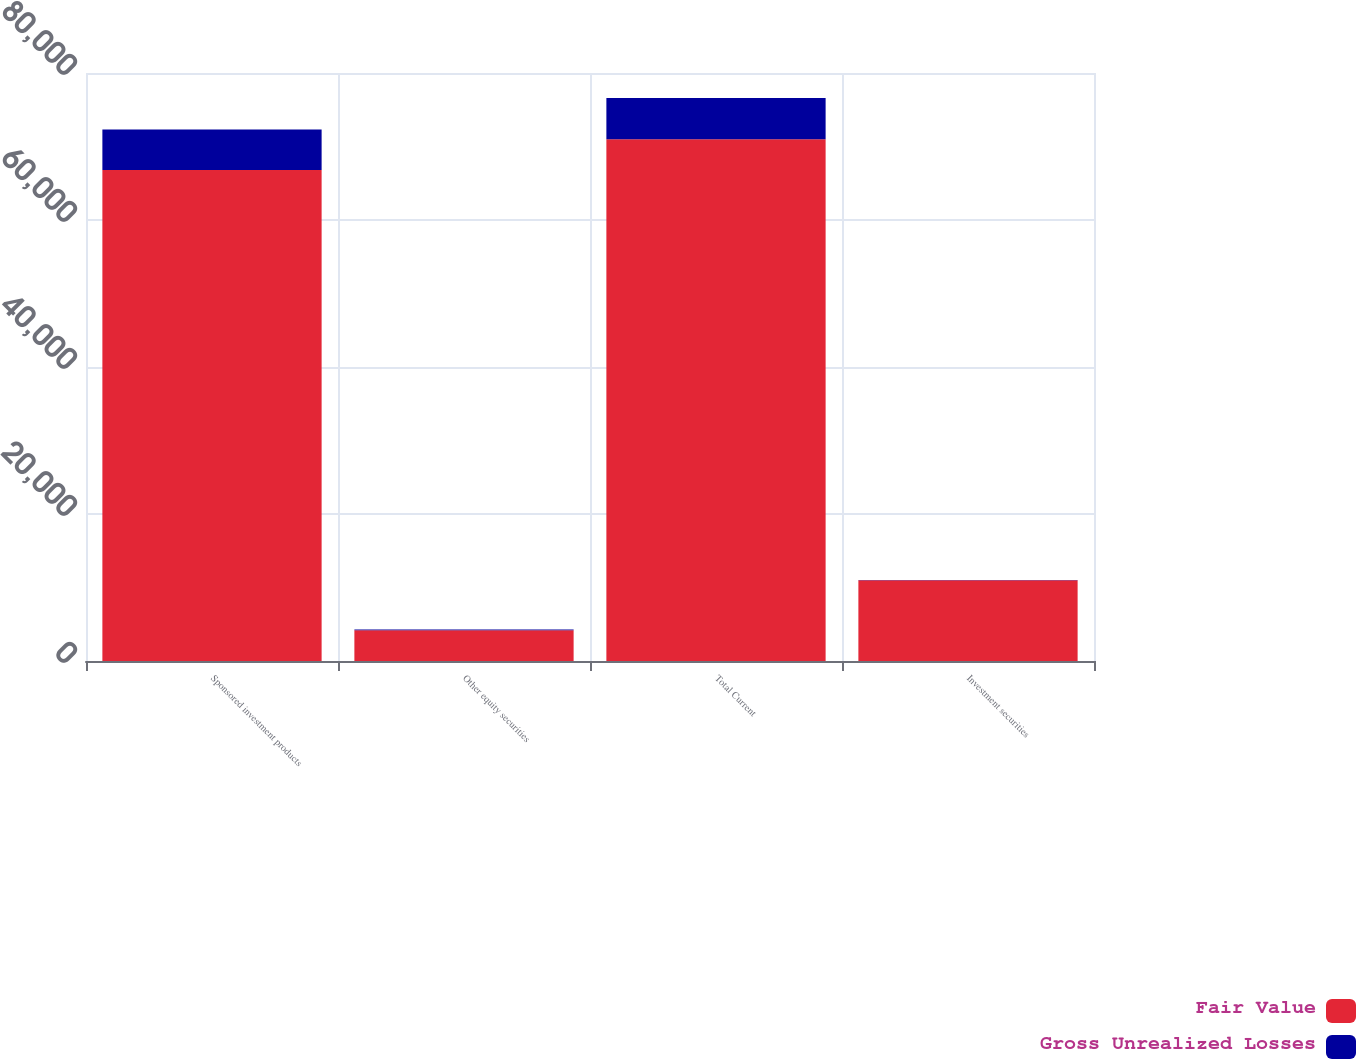<chart> <loc_0><loc_0><loc_500><loc_500><stacked_bar_chart><ecel><fcel>Sponsored investment products<fcel>Other equity securities<fcel>Total Current<fcel>Investment securities<nl><fcel>Fair Value<fcel>66816<fcel>4174<fcel>70990<fcel>11000<nl><fcel>Gross Unrealized Losses<fcel>5506<fcel>108<fcel>5614<fcel>10<nl></chart> 